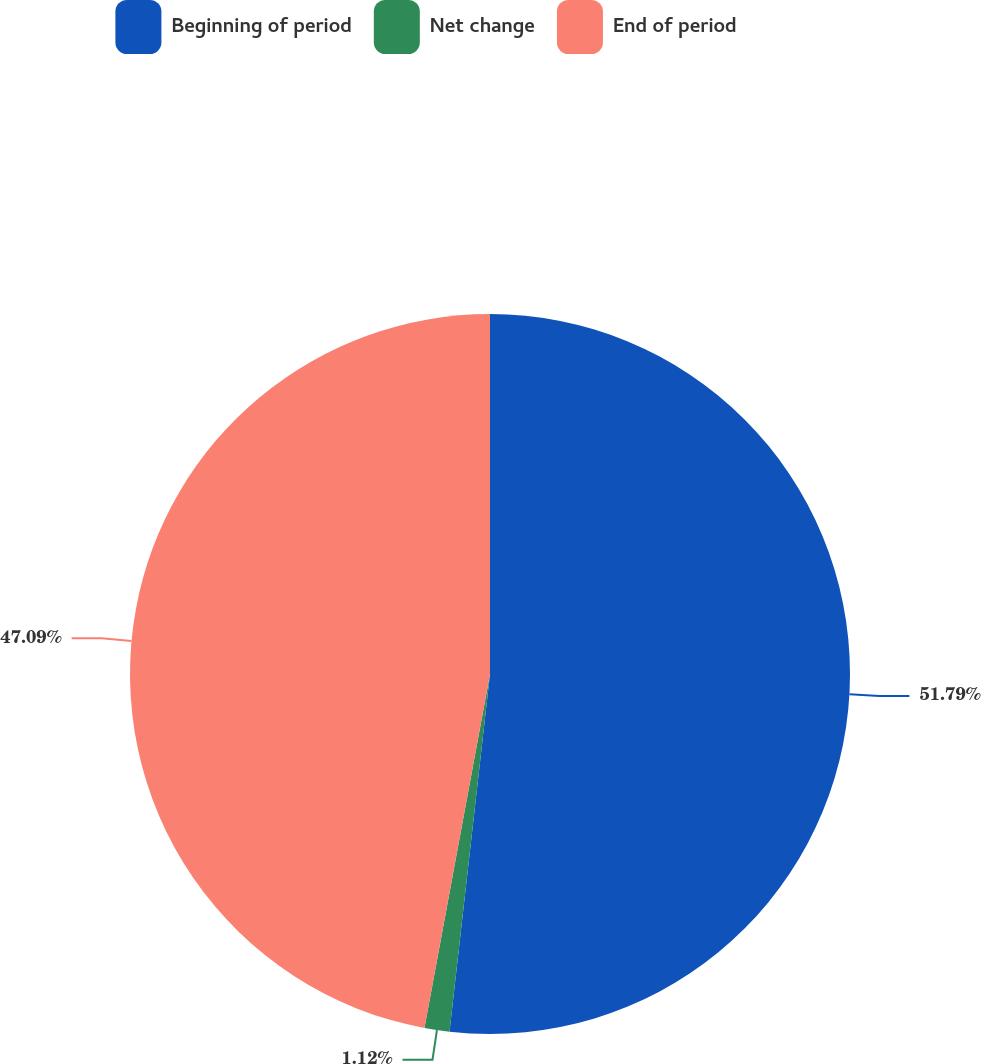<chart> <loc_0><loc_0><loc_500><loc_500><pie_chart><fcel>Beginning of period<fcel>Net change<fcel>End of period<nl><fcel>51.8%<fcel>1.12%<fcel>47.09%<nl></chart> 